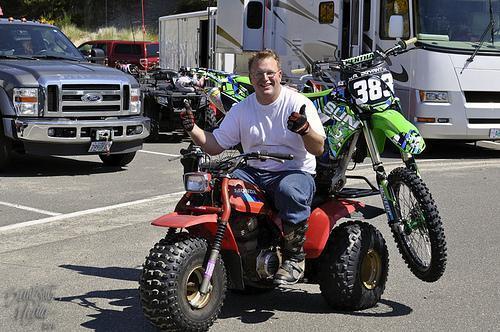How many license plates are visible?
Give a very brief answer. 2. 